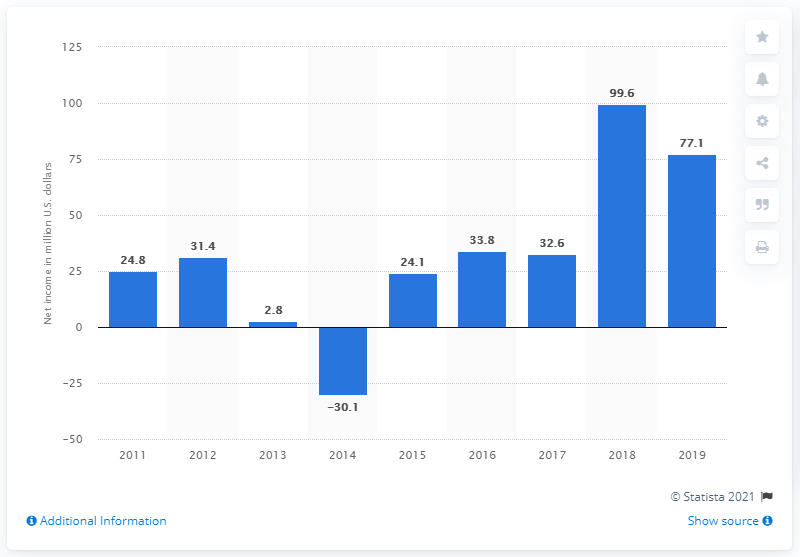Give some essential details in this illustration. World Wrestling Entertainment's net income from 2011 to 2019 was $77.1 million. 